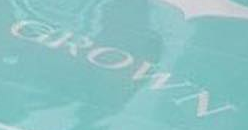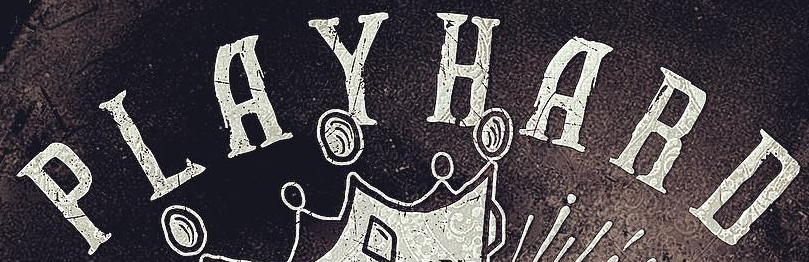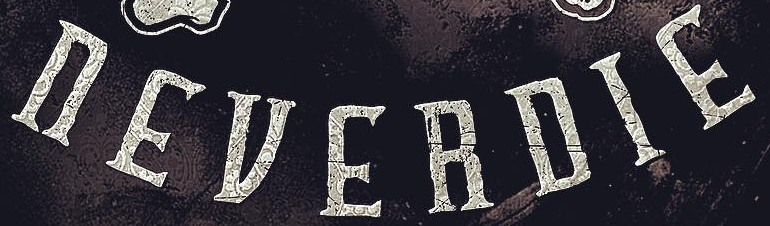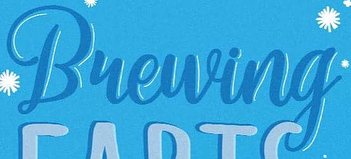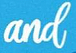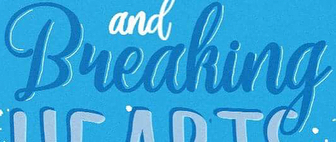What words are shown in these images in order, separated by a semicolon? GROWN; PLAYHARD; nEVERDIE; Bueuing; and; Bueaking 